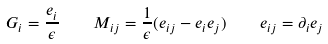Convert formula to latex. <formula><loc_0><loc_0><loc_500><loc_500>G _ { i } = \frac { e _ { i } } \epsilon \quad M _ { i j } = \frac { 1 } { \epsilon } ( e _ { i j } - e _ { i } e _ { j } ) \quad e _ { i j } = \partial _ { i } e _ { j }</formula> 